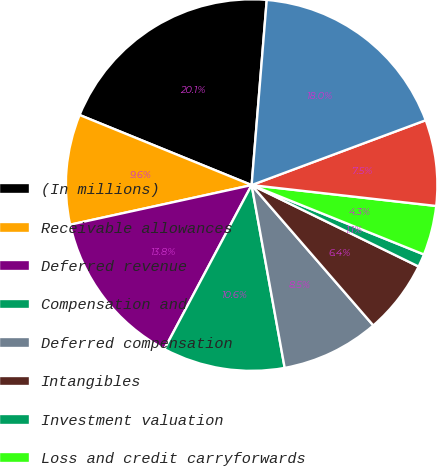Convert chart to OTSL. <chart><loc_0><loc_0><loc_500><loc_500><pie_chart><fcel>(In millions)<fcel>Receivable allowances<fcel>Deferred revenue<fcel>Compensation and<fcel>Deferred compensation<fcel>Intangibles<fcel>Investment valuation<fcel>Loss and credit carryforwards<fcel>Other<fcel>Subtotal<nl><fcel>20.14%<fcel>9.58%<fcel>13.8%<fcel>10.63%<fcel>8.52%<fcel>6.41%<fcel>1.13%<fcel>4.3%<fcel>7.47%<fcel>18.03%<nl></chart> 